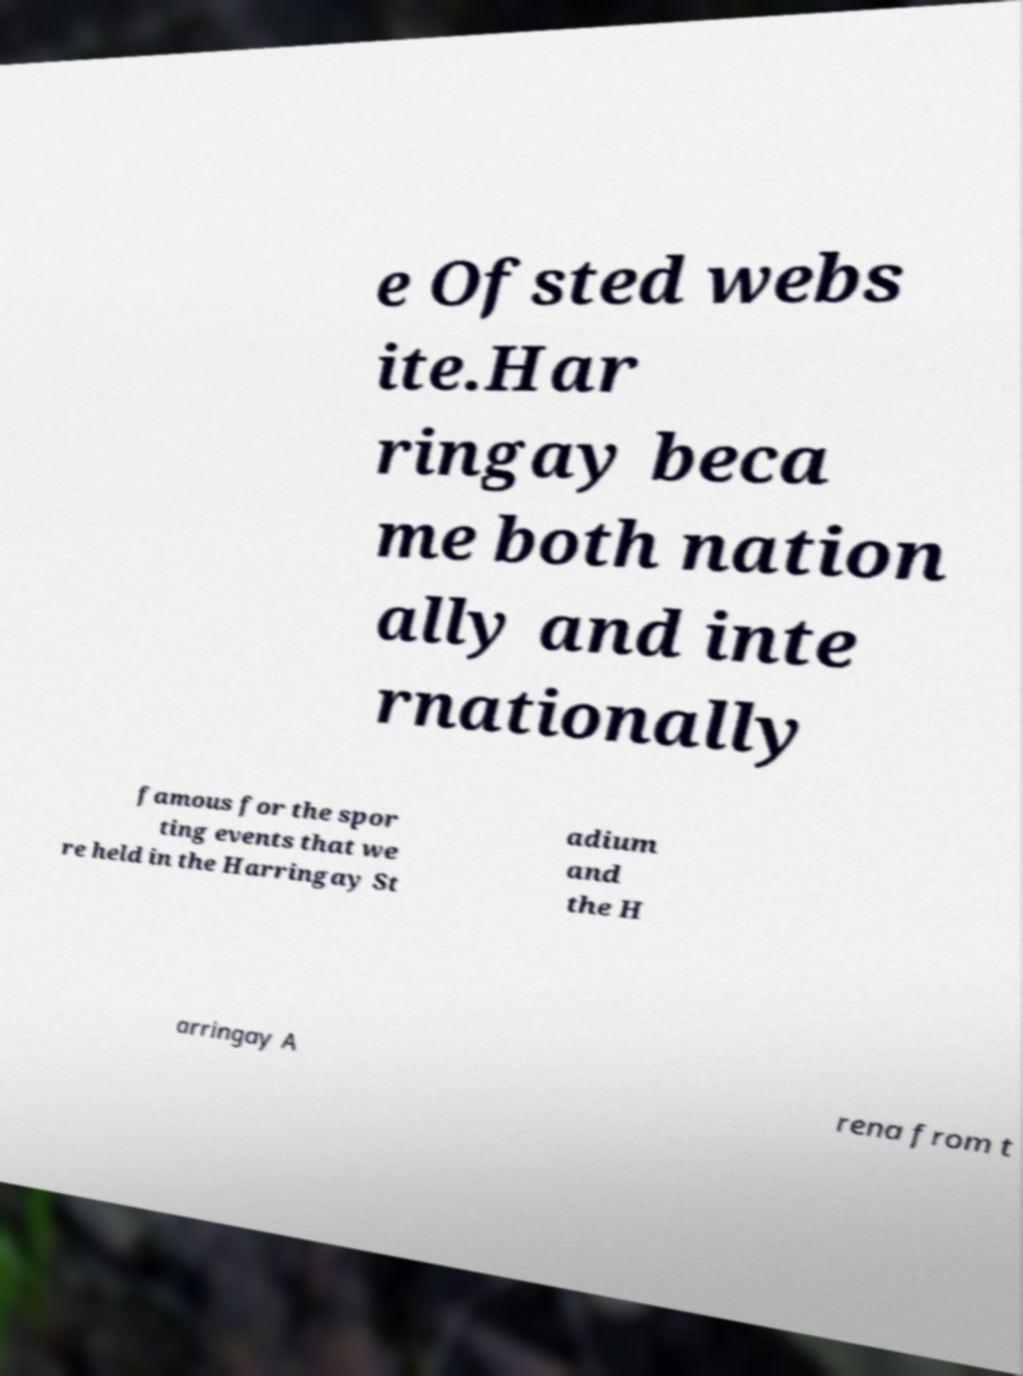Could you assist in decoding the text presented in this image and type it out clearly? e Ofsted webs ite.Har ringay beca me both nation ally and inte rnationally famous for the spor ting events that we re held in the Harringay St adium and the H arringay A rena from t 